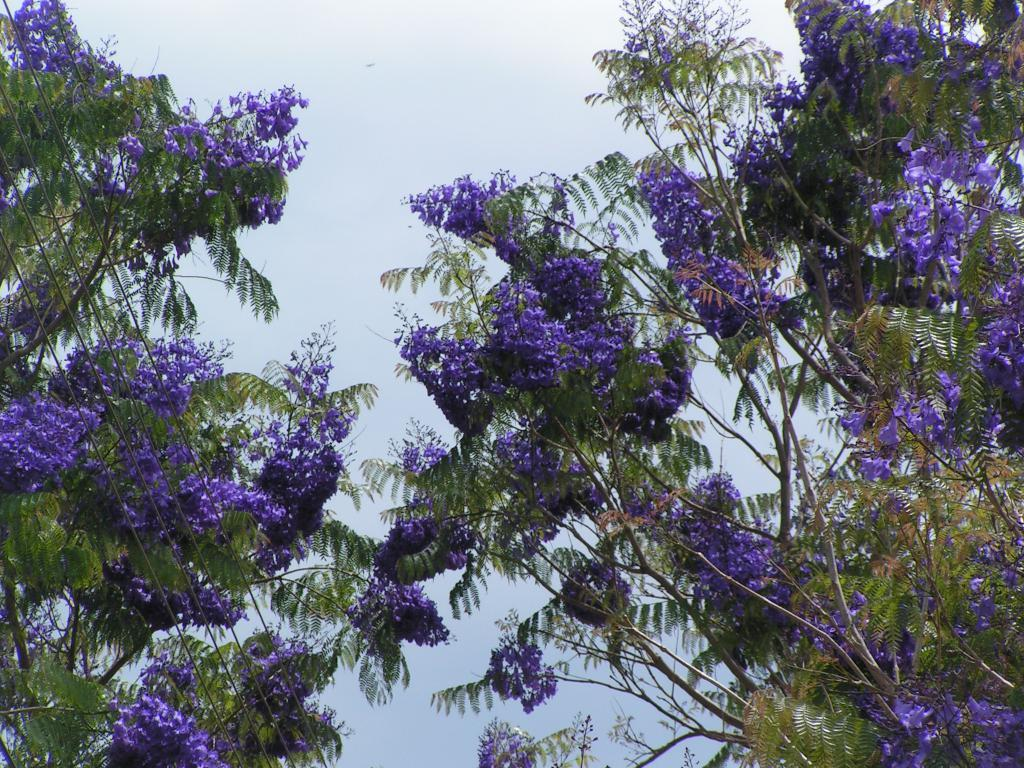What type of vegetation can be seen in the image? There are trees in the image. What part of the natural environment is visible in the image? The sky is visible in the image. How many pigs can be seen grazing in the patch of grass in the image? There are no pigs present in the image. 